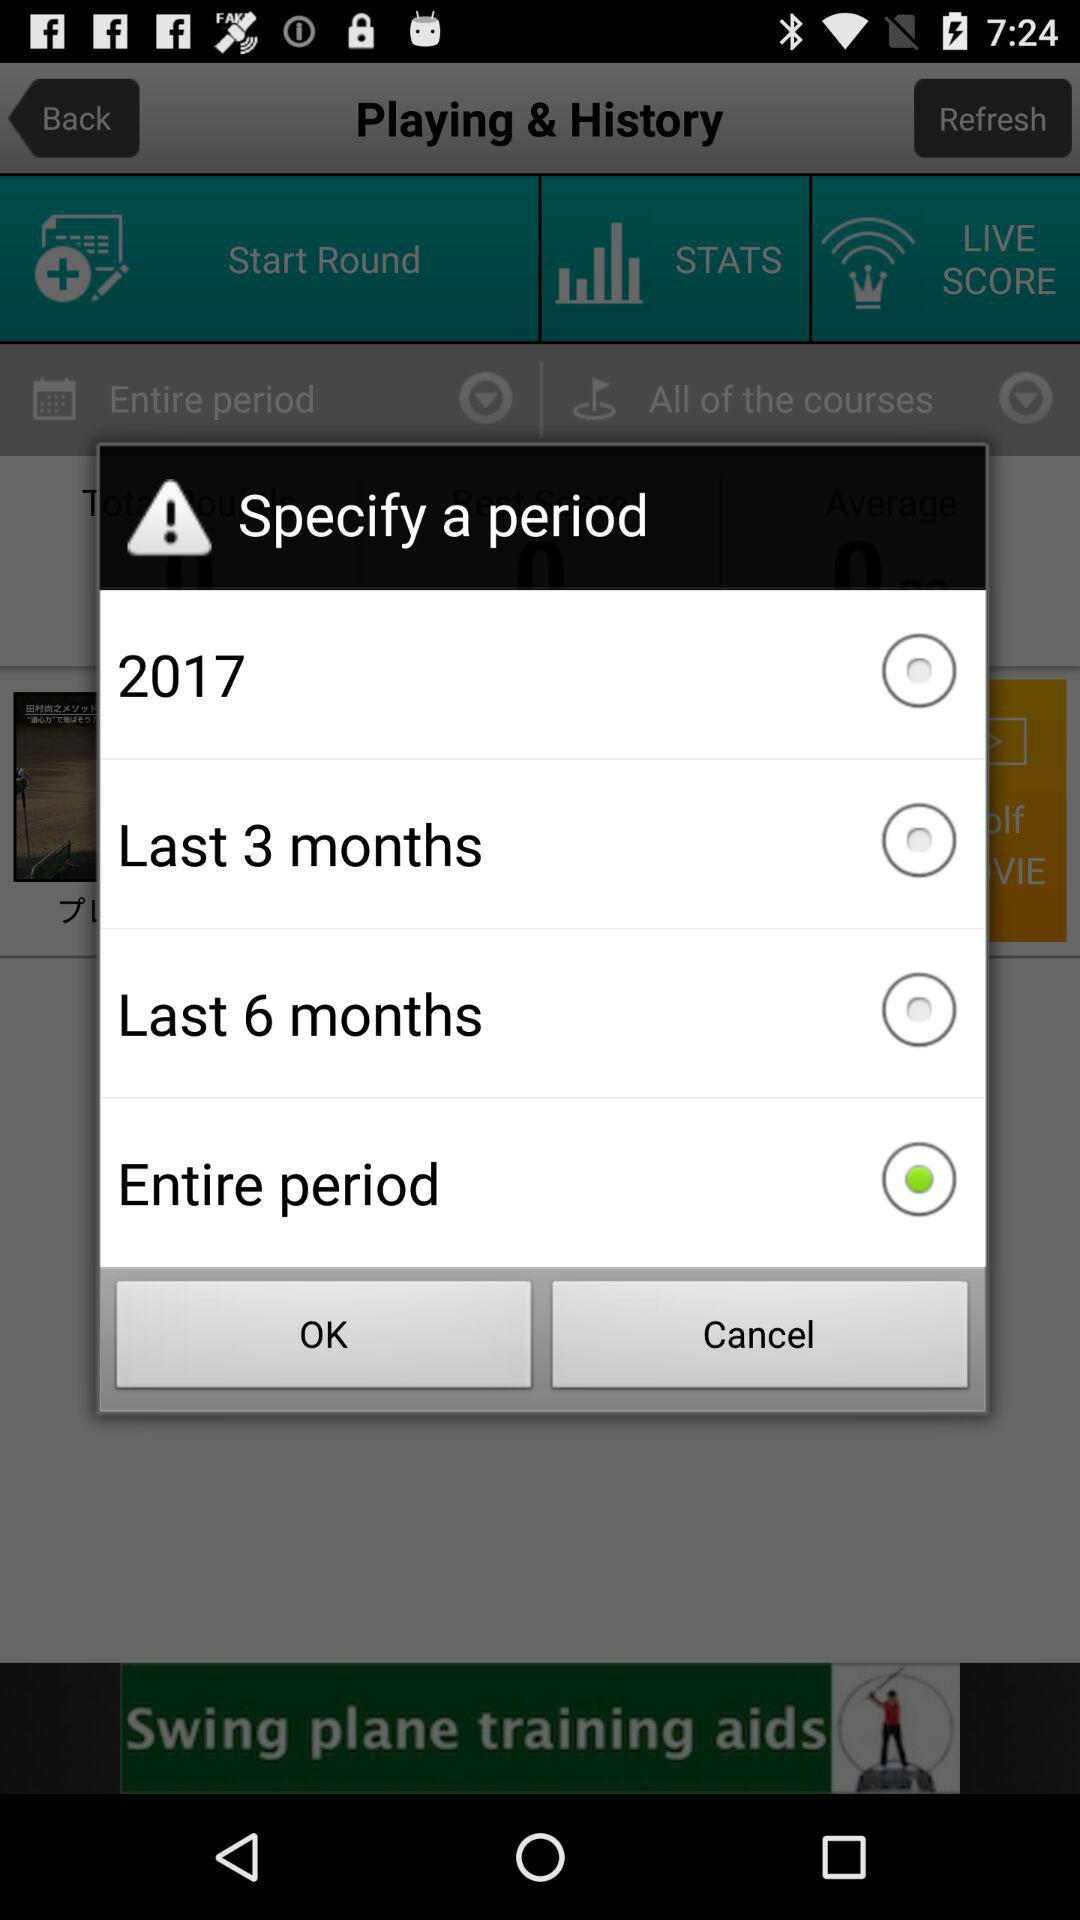Which option is selected in "Specify a period"? The selected option is "Entire period". 